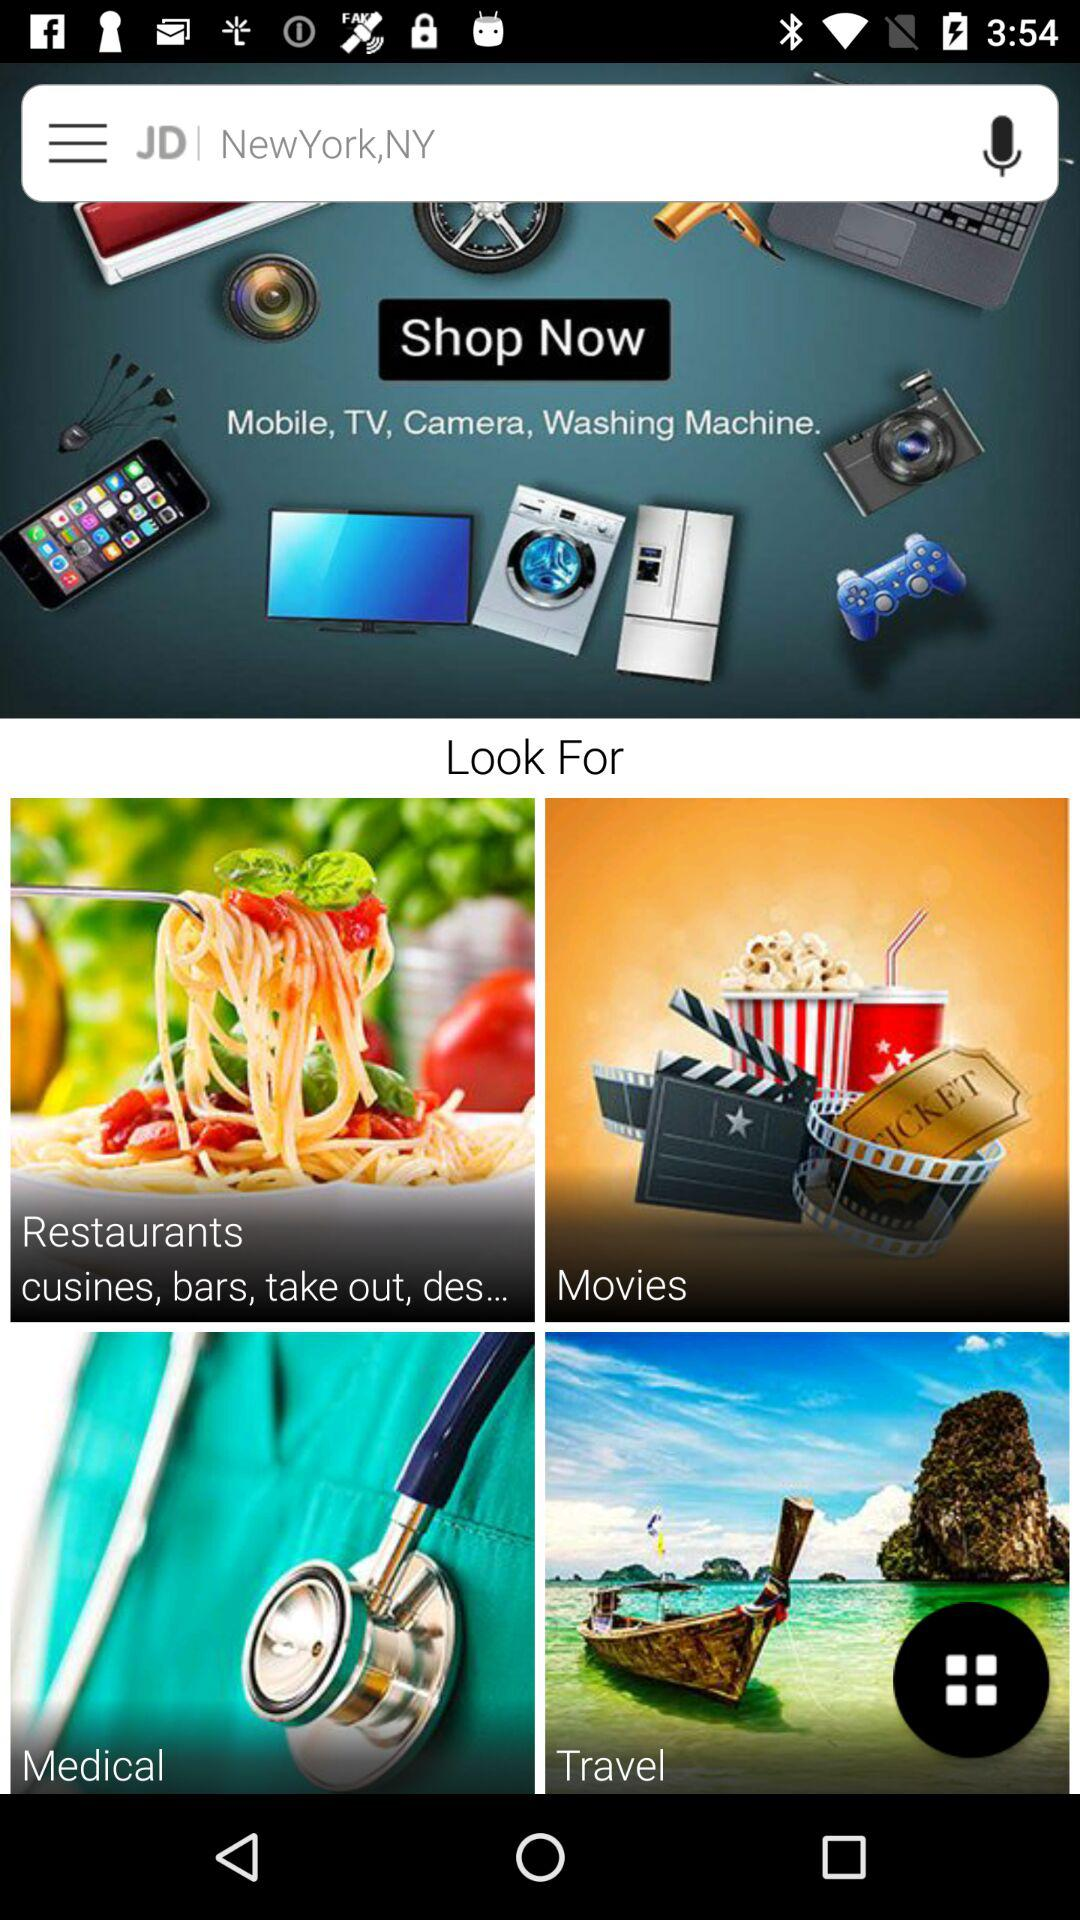What is the current location? The current location is "NewYork,NY". 